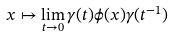Convert formula to latex. <formula><loc_0><loc_0><loc_500><loc_500>x \mapsto \lim _ { t \to 0 } \gamma ( t ) \phi ( x ) \gamma ( t ^ { - 1 } )</formula> 